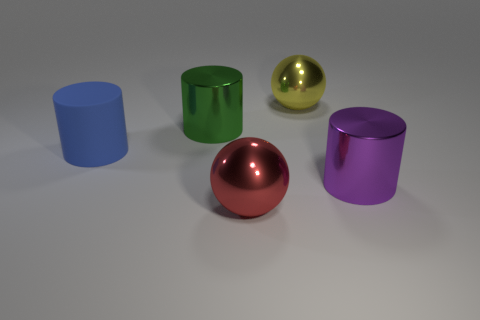There is a big yellow metallic thing behind the blue cylinder; what shape is it?
Your answer should be very brief. Sphere. What is the size of the purple thing that is the same shape as the blue rubber object?
Offer a very short reply. Large. How many objects are in front of the large metal ball that is to the left of the large sphere behind the large blue object?
Offer a terse response. 0. Is the number of spheres left of the yellow metal thing the same as the number of yellow shiny balls?
Provide a succinct answer. Yes. What number of balls are either blue rubber objects or red things?
Your response must be concise. 1. Is the number of balls that are on the left side of the matte cylinder the same as the number of green cylinders that are on the right side of the large red thing?
Your answer should be very brief. Yes. What is the color of the big matte thing?
Offer a very short reply. Blue. How many things are shiny objects behind the large red ball or big red metal things?
Provide a short and direct response. 4. There is a shiny cylinder in front of the rubber cylinder; does it have the same size as the red metallic sphere that is in front of the big yellow shiny ball?
Your answer should be very brief. Yes. Is there any other thing that is made of the same material as the large purple cylinder?
Ensure brevity in your answer.  Yes. 